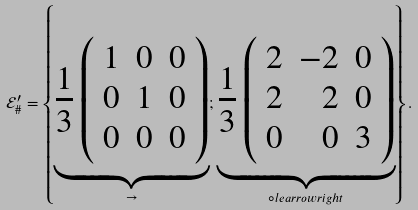<formula> <loc_0><loc_0><loc_500><loc_500>\mathcal { E } _ { \# } ^ { \prime } = \left \{ \underbrace { \frac { 1 } { 3 } \left ( \begin{array} { r r r } 1 & 0 & 0 \\ 0 & 1 & 0 \\ 0 & 0 & 0 \\ \end{array} \right ) } _ { \rightarrow } ; \underbrace { \frac { 1 } { 3 } \left ( \begin{array} { r r r } 2 & - 2 & 0 \\ 2 & 2 & 0 \\ 0 & 0 & 3 \\ \end{array} \right ) } _ { \circ l e a r r o w r i g h t } \right \} .</formula> 